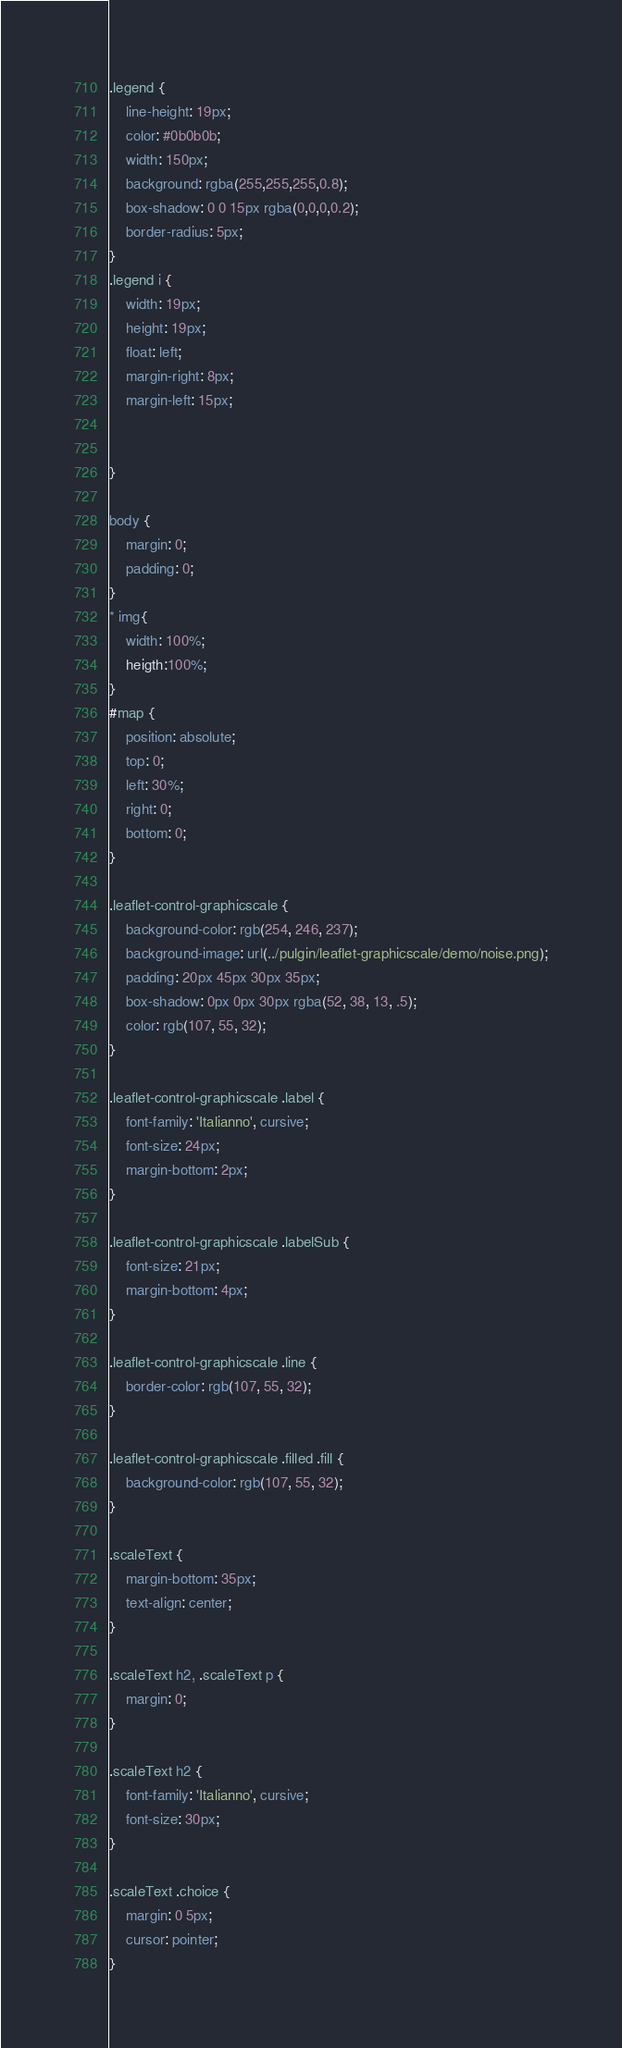Convert code to text. <code><loc_0><loc_0><loc_500><loc_500><_CSS_>.legend {
    line-height: 19px;
    color: #0b0b0b;
    width: 150px;
    background: rgba(255,255,255,0.8);
    box-shadow: 0 0 15px rgba(0,0,0,0.2);
    border-radius: 5px;
}
.legend i {
    width: 19px;
    height: 19px;
    float: left;
    margin-right: 8px;
    margin-left: 15px;


}

body {
    margin: 0;
    padding: 0;
}
* img{
    width: 100%;
    heigth:100%;
}
#map {
    position: absolute;
    top: 0;
    left: 30%;
    right: 0;
    bottom: 0;
}

.leaflet-control-graphicscale {
    background-color: rgb(254, 246, 237);
    background-image: url(../pulgin/leaflet-graphicscale/demo/noise.png);
    padding: 20px 45px 30px 35px;
    box-shadow: 0px 0px 30px rgba(52, 38, 13, .5);
    color: rgb(107, 55, 32);
}

.leaflet-control-graphicscale .label {
    font-family: 'Italianno', cursive;
    font-size: 24px;
    margin-bottom: 2px;
}

.leaflet-control-graphicscale .labelSub {
    font-size: 21px;
    margin-bottom: 4px;
}

.leaflet-control-graphicscale .line {
    border-color: rgb(107, 55, 32);
}

.leaflet-control-graphicscale .filled .fill {
    background-color: rgb(107, 55, 32);
}

.scaleText {
    margin-bottom: 35px;
    text-align: center;
}

.scaleText h2, .scaleText p {
    margin: 0;
}

.scaleText h2 {
    font-family: 'Italianno', cursive;
    font-size: 30px;
}

.scaleText .choice {
    margin: 0 5px;
    cursor: pointer;
}
</code> 